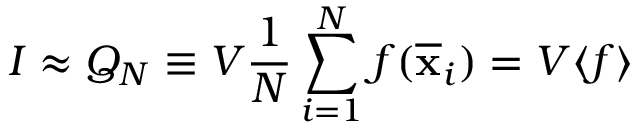Convert formula to latex. <formula><loc_0><loc_0><loc_500><loc_500>I \approx Q _ { N } \equiv V { \frac { 1 } { N } } \sum _ { i = 1 } ^ { N } f ( { \overline { x } } _ { i } ) = V \langle f \rangle</formula> 